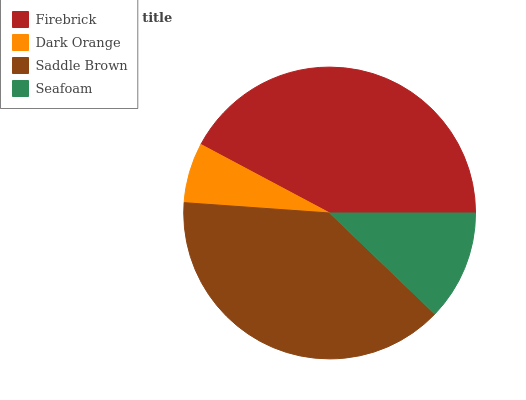Is Dark Orange the minimum?
Answer yes or no. Yes. Is Firebrick the maximum?
Answer yes or no. Yes. Is Saddle Brown the minimum?
Answer yes or no. No. Is Saddle Brown the maximum?
Answer yes or no. No. Is Saddle Brown greater than Dark Orange?
Answer yes or no. Yes. Is Dark Orange less than Saddle Brown?
Answer yes or no. Yes. Is Dark Orange greater than Saddle Brown?
Answer yes or no. No. Is Saddle Brown less than Dark Orange?
Answer yes or no. No. Is Saddle Brown the high median?
Answer yes or no. Yes. Is Seafoam the low median?
Answer yes or no. Yes. Is Dark Orange the high median?
Answer yes or no. No. Is Firebrick the low median?
Answer yes or no. No. 